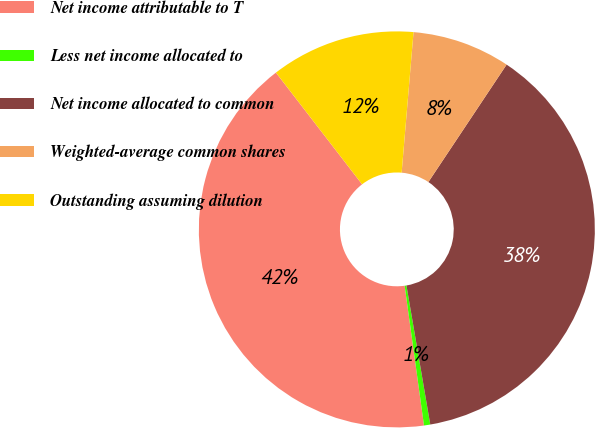Convert chart to OTSL. <chart><loc_0><loc_0><loc_500><loc_500><pie_chart><fcel>Net income attributable to T<fcel>Less net income allocated to<fcel>Net income allocated to common<fcel>Weighted-average common shares<fcel>Outstanding assuming dilution<nl><fcel>41.74%<fcel>0.51%<fcel>37.95%<fcel>8.01%<fcel>11.8%<nl></chart> 